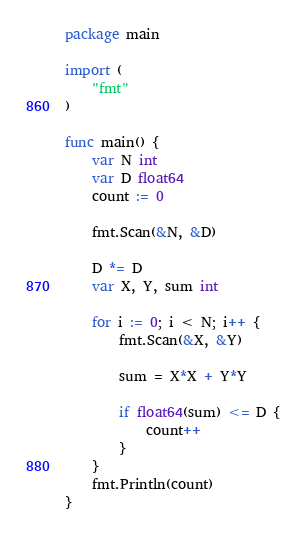<code> <loc_0><loc_0><loc_500><loc_500><_Go_>package main

import (
	"fmt"
)

func main() {
	var N int
	var D float64
	count := 0

	fmt.Scan(&N, &D)

	D *= D
	var X, Y, sum int

	for i := 0; i < N; i++ {
		fmt.Scan(&X, &Y)

		sum = X*X + Y*Y

		if float64(sum) <= D {
			count++
		}
	}
	fmt.Println(count)
}
</code> 